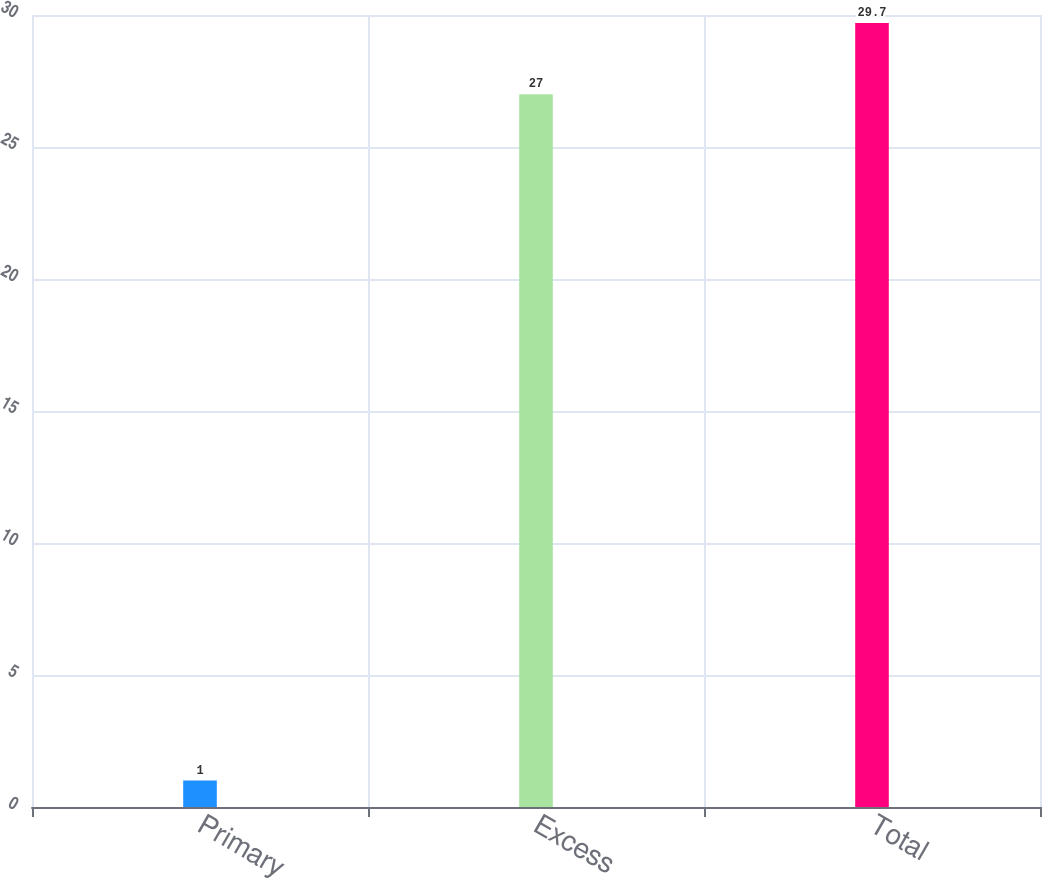Convert chart to OTSL. <chart><loc_0><loc_0><loc_500><loc_500><bar_chart><fcel>Primary<fcel>Excess<fcel>Total<nl><fcel>1<fcel>27<fcel>29.7<nl></chart> 